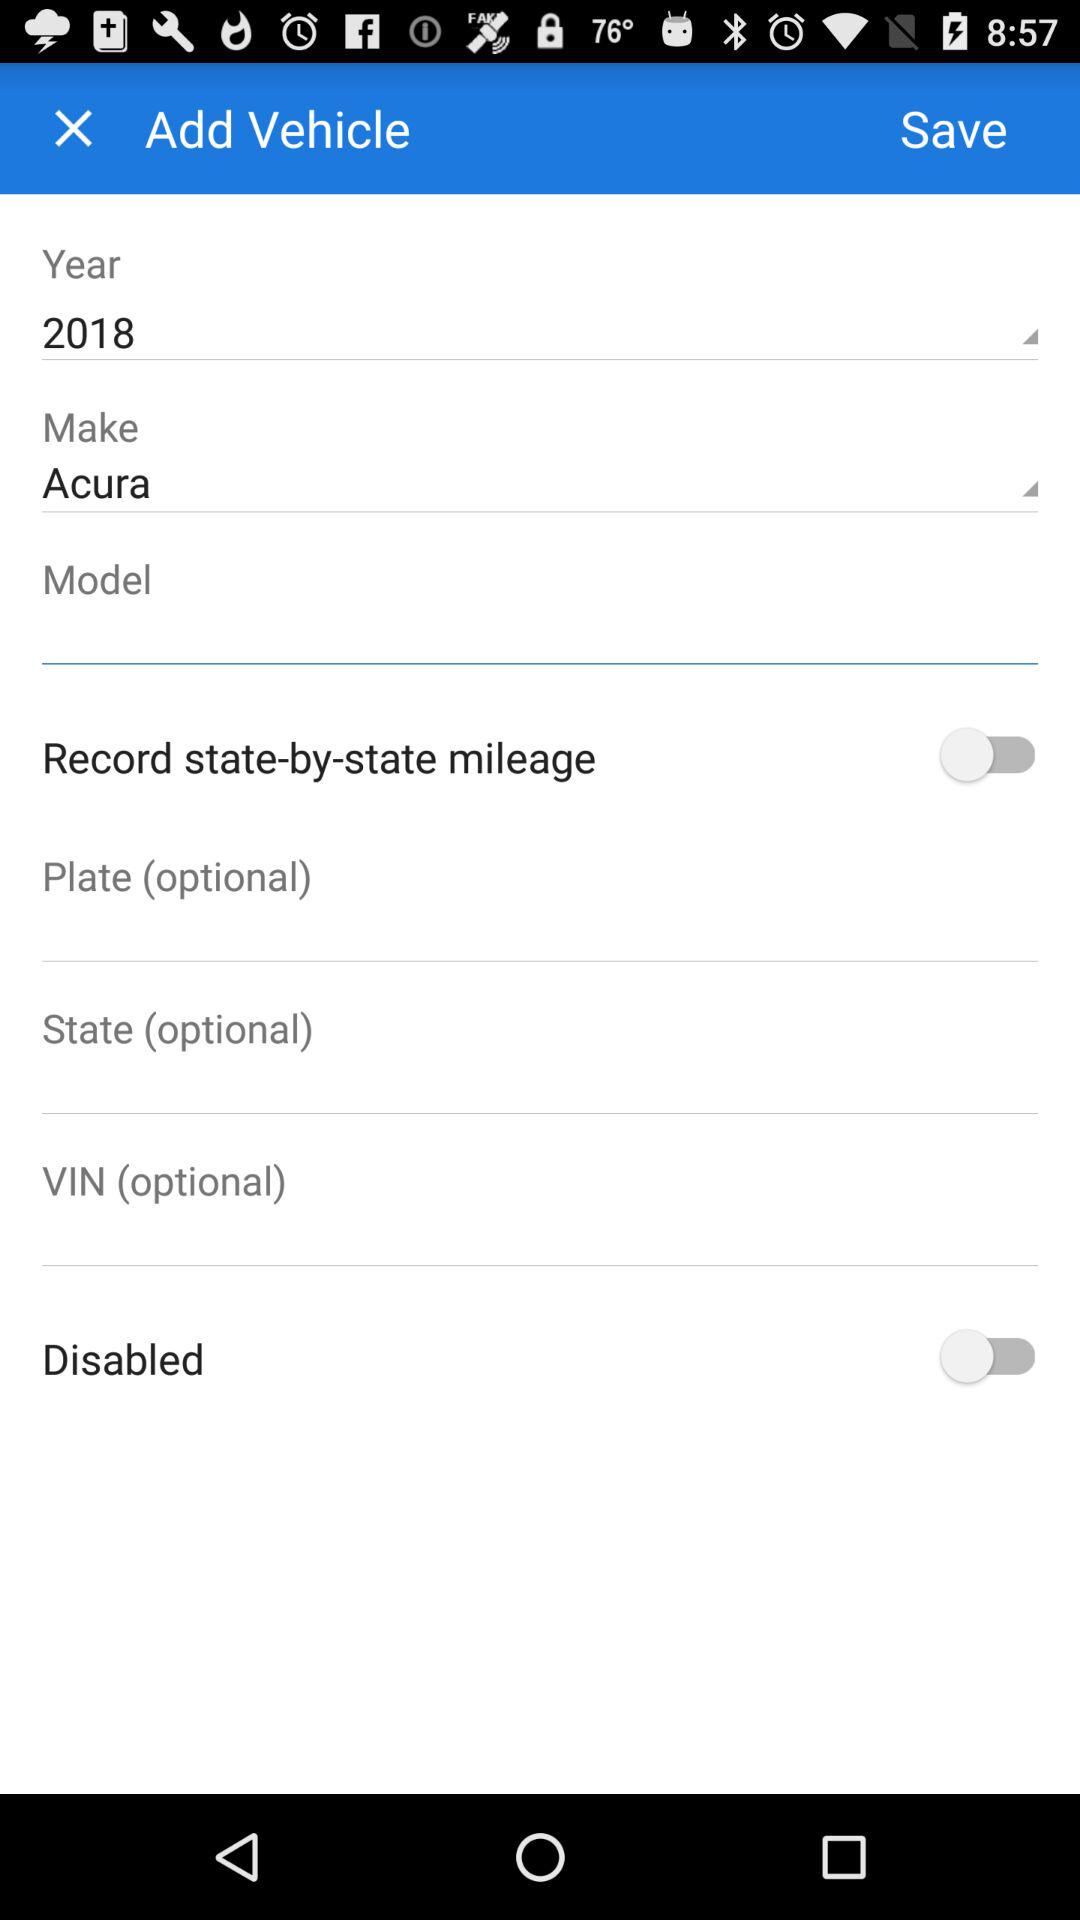Which "Make" is selected? The selected "Make" is "Acura". 